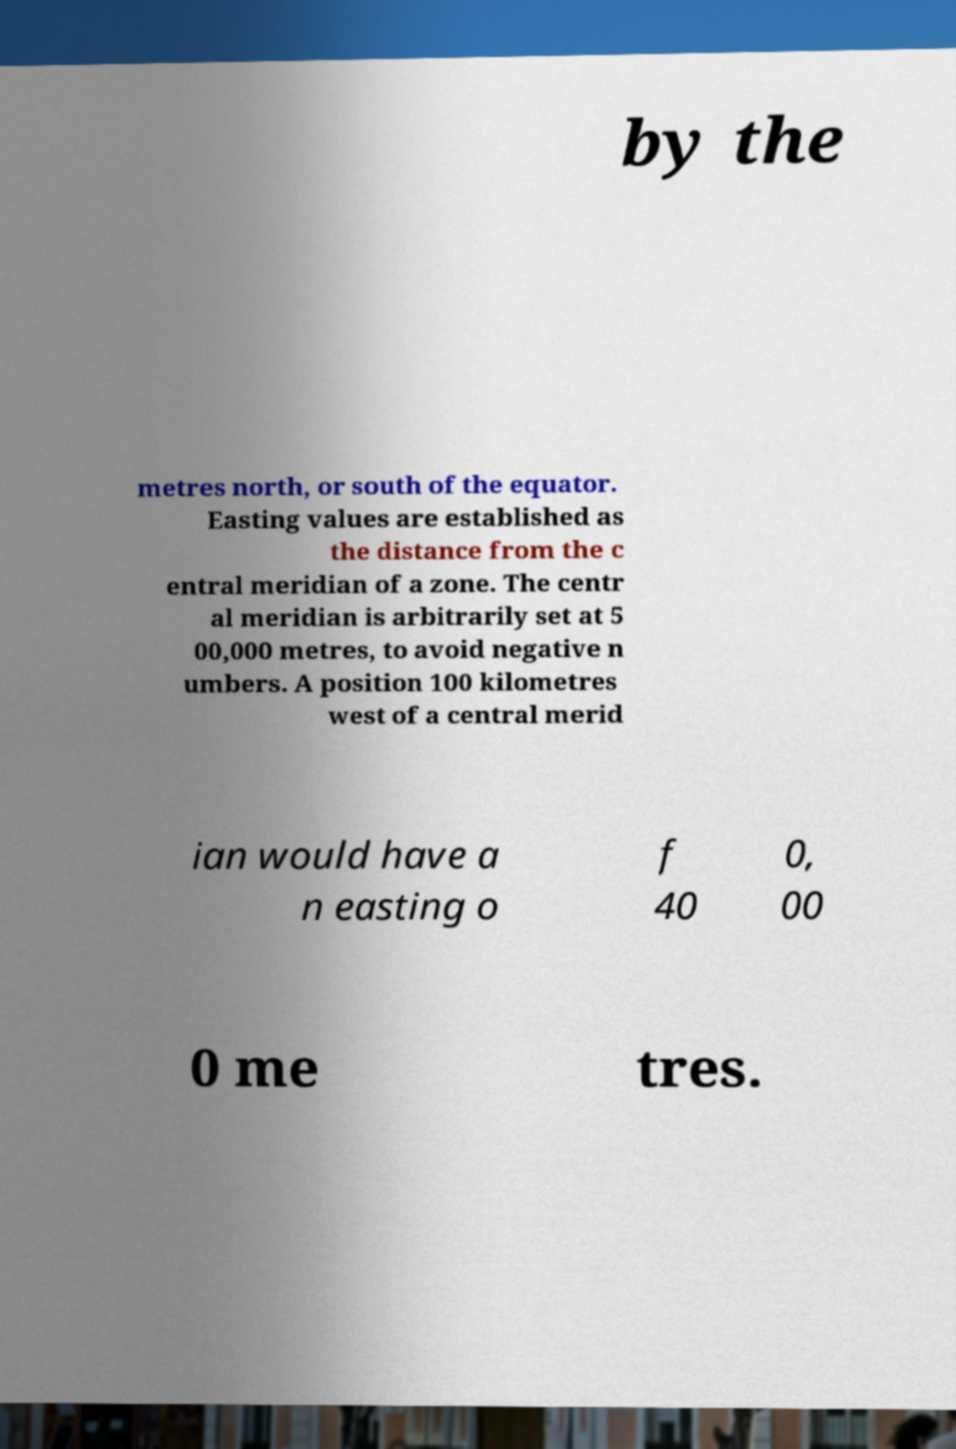Could you extract and type out the text from this image? by the metres north, or south of the equator. Easting values are established as the distance from the c entral meridian of a zone. The centr al meridian is arbitrarily set at 5 00,000 metres, to avoid negative n umbers. A position 100 kilometres west of a central merid ian would have a n easting o f 40 0, 00 0 me tres. 